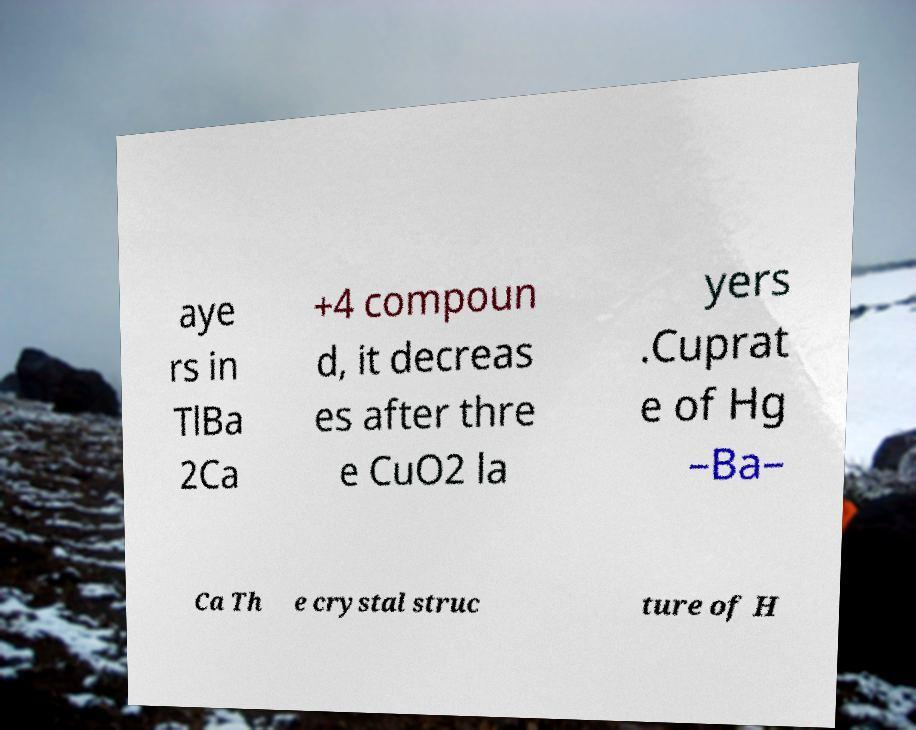Could you extract and type out the text from this image? aye rs in TlBa 2Ca +4 compoun d, it decreas es after thre e CuO2 la yers .Cuprat e of Hg –Ba– Ca Th e crystal struc ture of H 